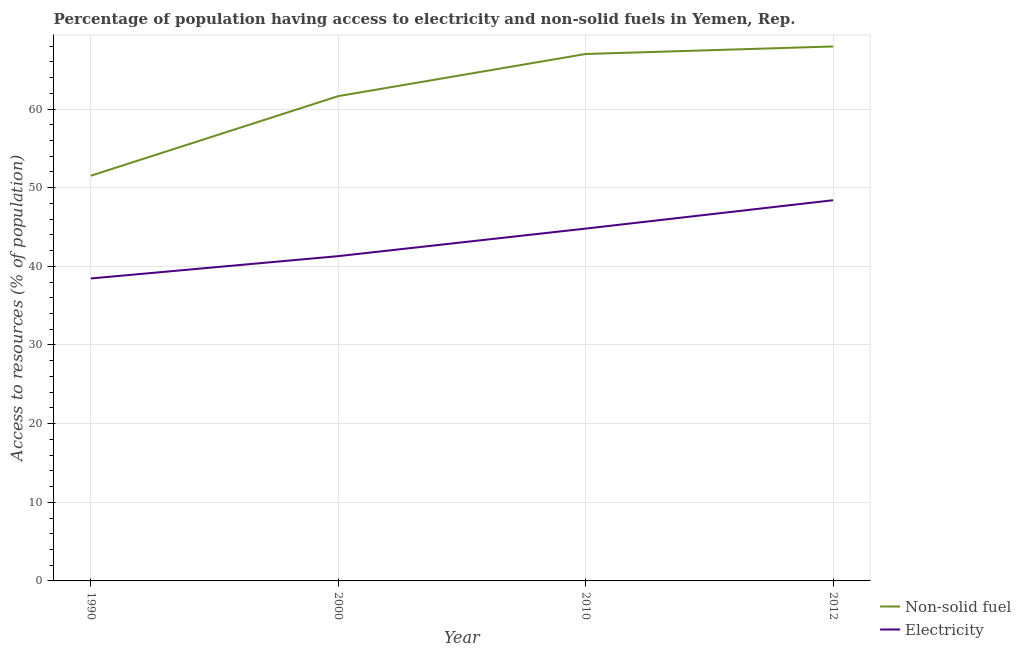Does the line corresponding to percentage of population having access to electricity intersect with the line corresponding to percentage of population having access to non-solid fuel?
Make the answer very short. No. What is the percentage of population having access to electricity in 1990?
Make the answer very short. 38.46. Across all years, what is the maximum percentage of population having access to electricity?
Your answer should be very brief. 48.41. Across all years, what is the minimum percentage of population having access to electricity?
Make the answer very short. 38.46. In which year was the percentage of population having access to electricity maximum?
Make the answer very short. 2012. In which year was the percentage of population having access to non-solid fuel minimum?
Provide a succinct answer. 1990. What is the total percentage of population having access to electricity in the graph?
Provide a succinct answer. 172.97. What is the difference between the percentage of population having access to electricity in 2010 and that in 2012?
Offer a terse response. -3.61. What is the difference between the percentage of population having access to electricity in 1990 and the percentage of population having access to non-solid fuel in 2012?
Provide a succinct answer. -29.5. What is the average percentage of population having access to non-solid fuel per year?
Your response must be concise. 62.03. In the year 2012, what is the difference between the percentage of population having access to non-solid fuel and percentage of population having access to electricity?
Provide a short and direct response. 19.55. In how many years, is the percentage of population having access to non-solid fuel greater than 38 %?
Your answer should be very brief. 4. What is the ratio of the percentage of population having access to non-solid fuel in 2000 to that in 2012?
Offer a terse response. 0.91. What is the difference between the highest and the second highest percentage of population having access to electricity?
Offer a terse response. 3.61. What is the difference between the highest and the lowest percentage of population having access to non-solid fuel?
Offer a very short reply. 16.44. In how many years, is the percentage of population having access to electricity greater than the average percentage of population having access to electricity taken over all years?
Your response must be concise. 2. Is the percentage of population having access to non-solid fuel strictly greater than the percentage of population having access to electricity over the years?
Offer a very short reply. Yes. How many lines are there?
Your response must be concise. 2. How many years are there in the graph?
Provide a short and direct response. 4. What is the difference between two consecutive major ticks on the Y-axis?
Offer a terse response. 10. Are the values on the major ticks of Y-axis written in scientific E-notation?
Offer a terse response. No. What is the title of the graph?
Offer a very short reply. Percentage of population having access to electricity and non-solid fuels in Yemen, Rep. Does "Banks" appear as one of the legend labels in the graph?
Offer a terse response. No. What is the label or title of the X-axis?
Provide a short and direct response. Year. What is the label or title of the Y-axis?
Your answer should be compact. Access to resources (% of population). What is the Access to resources (% of population) in Non-solid fuel in 1990?
Provide a short and direct response. 51.52. What is the Access to resources (% of population) in Electricity in 1990?
Make the answer very short. 38.46. What is the Access to resources (% of population) in Non-solid fuel in 2000?
Your answer should be very brief. 61.64. What is the Access to resources (% of population) in Electricity in 2000?
Your response must be concise. 41.3. What is the Access to resources (% of population) in Non-solid fuel in 2010?
Provide a short and direct response. 67. What is the Access to resources (% of population) in Electricity in 2010?
Make the answer very short. 44.8. What is the Access to resources (% of population) of Non-solid fuel in 2012?
Offer a very short reply. 67.96. What is the Access to resources (% of population) of Electricity in 2012?
Give a very brief answer. 48.41. Across all years, what is the maximum Access to resources (% of population) of Non-solid fuel?
Your answer should be very brief. 67.96. Across all years, what is the maximum Access to resources (% of population) of Electricity?
Give a very brief answer. 48.41. Across all years, what is the minimum Access to resources (% of population) of Non-solid fuel?
Give a very brief answer. 51.52. Across all years, what is the minimum Access to resources (% of population) of Electricity?
Your answer should be compact. 38.46. What is the total Access to resources (% of population) of Non-solid fuel in the graph?
Make the answer very short. 248.13. What is the total Access to resources (% of population) of Electricity in the graph?
Offer a terse response. 172.97. What is the difference between the Access to resources (% of population) in Non-solid fuel in 1990 and that in 2000?
Offer a very short reply. -10.12. What is the difference between the Access to resources (% of population) in Electricity in 1990 and that in 2000?
Offer a very short reply. -2.84. What is the difference between the Access to resources (% of population) of Non-solid fuel in 1990 and that in 2010?
Provide a succinct answer. -15.48. What is the difference between the Access to resources (% of population) in Electricity in 1990 and that in 2010?
Offer a terse response. -6.34. What is the difference between the Access to resources (% of population) in Non-solid fuel in 1990 and that in 2012?
Provide a succinct answer. -16.44. What is the difference between the Access to resources (% of population) of Electricity in 1990 and that in 2012?
Your answer should be compact. -9.95. What is the difference between the Access to resources (% of population) in Non-solid fuel in 2000 and that in 2010?
Offer a terse response. -5.36. What is the difference between the Access to resources (% of population) of Electricity in 2000 and that in 2010?
Keep it short and to the point. -3.5. What is the difference between the Access to resources (% of population) of Non-solid fuel in 2000 and that in 2012?
Make the answer very short. -6.32. What is the difference between the Access to resources (% of population) of Electricity in 2000 and that in 2012?
Offer a very short reply. -7.11. What is the difference between the Access to resources (% of population) in Non-solid fuel in 2010 and that in 2012?
Offer a very short reply. -0.96. What is the difference between the Access to resources (% of population) of Electricity in 2010 and that in 2012?
Your answer should be very brief. -3.61. What is the difference between the Access to resources (% of population) of Non-solid fuel in 1990 and the Access to resources (% of population) of Electricity in 2000?
Make the answer very short. 10.22. What is the difference between the Access to resources (% of population) of Non-solid fuel in 1990 and the Access to resources (% of population) of Electricity in 2010?
Offer a terse response. 6.72. What is the difference between the Access to resources (% of population) of Non-solid fuel in 1990 and the Access to resources (% of population) of Electricity in 2012?
Your answer should be compact. 3.12. What is the difference between the Access to resources (% of population) of Non-solid fuel in 2000 and the Access to resources (% of population) of Electricity in 2010?
Ensure brevity in your answer.  16.84. What is the difference between the Access to resources (% of population) in Non-solid fuel in 2000 and the Access to resources (% of population) in Electricity in 2012?
Your answer should be very brief. 13.24. What is the difference between the Access to resources (% of population) in Non-solid fuel in 2010 and the Access to resources (% of population) in Electricity in 2012?
Keep it short and to the point. 18.6. What is the average Access to resources (% of population) in Non-solid fuel per year?
Your answer should be very brief. 62.03. What is the average Access to resources (% of population) of Electricity per year?
Your answer should be compact. 43.24. In the year 1990, what is the difference between the Access to resources (% of population) in Non-solid fuel and Access to resources (% of population) in Electricity?
Give a very brief answer. 13.06. In the year 2000, what is the difference between the Access to resources (% of population) of Non-solid fuel and Access to resources (% of population) of Electricity?
Offer a terse response. 20.34. In the year 2010, what is the difference between the Access to resources (% of population) of Non-solid fuel and Access to resources (% of population) of Electricity?
Provide a succinct answer. 22.2. In the year 2012, what is the difference between the Access to resources (% of population) of Non-solid fuel and Access to resources (% of population) of Electricity?
Give a very brief answer. 19.55. What is the ratio of the Access to resources (% of population) of Non-solid fuel in 1990 to that in 2000?
Ensure brevity in your answer.  0.84. What is the ratio of the Access to resources (% of population) in Electricity in 1990 to that in 2000?
Make the answer very short. 0.93. What is the ratio of the Access to resources (% of population) of Non-solid fuel in 1990 to that in 2010?
Your answer should be compact. 0.77. What is the ratio of the Access to resources (% of population) of Electricity in 1990 to that in 2010?
Provide a short and direct response. 0.86. What is the ratio of the Access to resources (% of population) of Non-solid fuel in 1990 to that in 2012?
Make the answer very short. 0.76. What is the ratio of the Access to resources (% of population) of Electricity in 1990 to that in 2012?
Your answer should be very brief. 0.79. What is the ratio of the Access to resources (% of population) of Electricity in 2000 to that in 2010?
Give a very brief answer. 0.92. What is the ratio of the Access to resources (% of population) in Non-solid fuel in 2000 to that in 2012?
Offer a very short reply. 0.91. What is the ratio of the Access to resources (% of population) of Electricity in 2000 to that in 2012?
Make the answer very short. 0.85. What is the ratio of the Access to resources (% of population) of Non-solid fuel in 2010 to that in 2012?
Your answer should be very brief. 0.99. What is the ratio of the Access to resources (% of population) of Electricity in 2010 to that in 2012?
Offer a very short reply. 0.93. What is the difference between the highest and the second highest Access to resources (% of population) in Non-solid fuel?
Give a very brief answer. 0.96. What is the difference between the highest and the second highest Access to resources (% of population) of Electricity?
Your answer should be very brief. 3.61. What is the difference between the highest and the lowest Access to resources (% of population) in Non-solid fuel?
Your response must be concise. 16.44. What is the difference between the highest and the lowest Access to resources (% of population) of Electricity?
Provide a short and direct response. 9.95. 